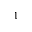Convert formula to latex. <formula><loc_0><loc_0><loc_500><loc_500>_ { 1 }</formula> 